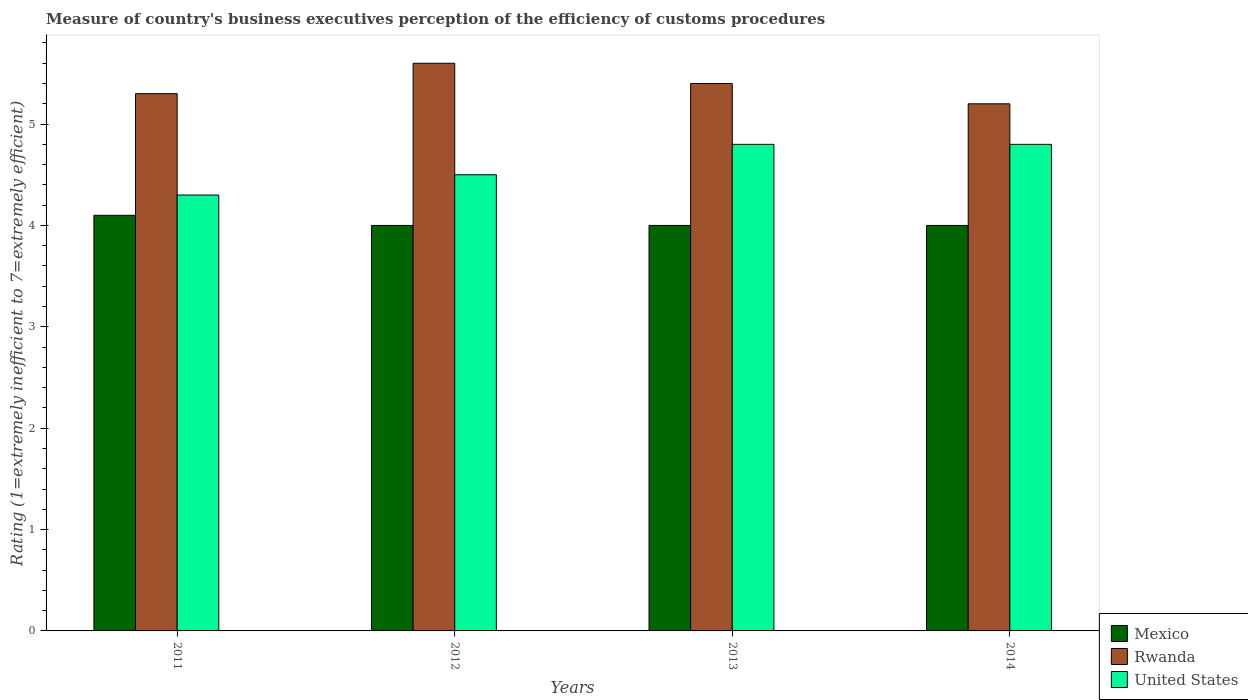Are the number of bars per tick equal to the number of legend labels?
Keep it short and to the point. Yes. How many bars are there on the 2nd tick from the left?
Offer a very short reply. 3. In how many cases, is the number of bars for a given year not equal to the number of legend labels?
Your response must be concise. 0. Across all years, what is the minimum rating of the efficiency of customs procedure in Mexico?
Ensure brevity in your answer.  4. What is the total rating of the efficiency of customs procedure in Rwanda in the graph?
Provide a short and direct response. 21.5. What is the difference between the rating of the efficiency of customs procedure in United States in 2011 and that in 2012?
Ensure brevity in your answer.  -0.2. What is the difference between the rating of the efficiency of customs procedure in Mexico in 2011 and the rating of the efficiency of customs procedure in United States in 2014?
Ensure brevity in your answer.  -0.7. What is the average rating of the efficiency of customs procedure in Mexico per year?
Your answer should be compact. 4.03. What is the ratio of the rating of the efficiency of customs procedure in Rwanda in 2011 to that in 2013?
Give a very brief answer. 0.98. Is the difference between the rating of the efficiency of customs procedure in Rwanda in 2011 and 2012 greater than the difference between the rating of the efficiency of customs procedure in United States in 2011 and 2012?
Offer a very short reply. No. What is the difference between the highest and the second highest rating of the efficiency of customs procedure in Rwanda?
Provide a short and direct response. 0.2. What is the difference between the highest and the lowest rating of the efficiency of customs procedure in Rwanda?
Make the answer very short. 0.4. What does the 2nd bar from the right in 2011 represents?
Your answer should be compact. Rwanda. Is it the case that in every year, the sum of the rating of the efficiency of customs procedure in Mexico and rating of the efficiency of customs procedure in United States is greater than the rating of the efficiency of customs procedure in Rwanda?
Offer a very short reply. Yes. Does the graph contain grids?
Your answer should be compact. No. Where does the legend appear in the graph?
Offer a very short reply. Bottom right. How many legend labels are there?
Your response must be concise. 3. How are the legend labels stacked?
Provide a short and direct response. Vertical. What is the title of the graph?
Your response must be concise. Measure of country's business executives perception of the efficiency of customs procedures. What is the label or title of the Y-axis?
Provide a succinct answer. Rating (1=extremely inefficient to 7=extremely efficient). What is the Rating (1=extremely inefficient to 7=extremely efficient) of Mexico in 2011?
Your response must be concise. 4.1. What is the Rating (1=extremely inefficient to 7=extremely efficient) of Mexico in 2012?
Your answer should be very brief. 4. What is the Rating (1=extremely inefficient to 7=extremely efficient) of Mexico in 2014?
Give a very brief answer. 4. What is the Rating (1=extremely inefficient to 7=extremely efficient) of Rwanda in 2014?
Your response must be concise. 5.2. What is the Rating (1=extremely inefficient to 7=extremely efficient) in United States in 2014?
Offer a terse response. 4.8. Across all years, what is the minimum Rating (1=extremely inefficient to 7=extremely efficient) in Rwanda?
Your response must be concise. 5.2. What is the total Rating (1=extremely inefficient to 7=extremely efficient) of Rwanda in the graph?
Your answer should be compact. 21.5. What is the total Rating (1=extremely inefficient to 7=extremely efficient) in United States in the graph?
Ensure brevity in your answer.  18.4. What is the difference between the Rating (1=extremely inefficient to 7=extremely efficient) of Mexico in 2011 and that in 2012?
Provide a short and direct response. 0.1. What is the difference between the Rating (1=extremely inefficient to 7=extremely efficient) in United States in 2011 and that in 2012?
Your answer should be very brief. -0.2. What is the difference between the Rating (1=extremely inefficient to 7=extremely efficient) of Mexico in 2011 and that in 2013?
Give a very brief answer. 0.1. What is the difference between the Rating (1=extremely inefficient to 7=extremely efficient) of Mexico in 2011 and that in 2014?
Provide a short and direct response. 0.1. What is the difference between the Rating (1=extremely inefficient to 7=extremely efficient) in United States in 2011 and that in 2014?
Your answer should be very brief. -0.5. What is the difference between the Rating (1=extremely inefficient to 7=extremely efficient) in Mexico in 2012 and that in 2013?
Your response must be concise. 0. What is the difference between the Rating (1=extremely inefficient to 7=extremely efficient) in United States in 2012 and that in 2013?
Give a very brief answer. -0.3. What is the difference between the Rating (1=extremely inefficient to 7=extremely efficient) of Mexico in 2012 and that in 2014?
Make the answer very short. 0. What is the difference between the Rating (1=extremely inefficient to 7=extremely efficient) in United States in 2013 and that in 2014?
Your response must be concise. 0. What is the difference between the Rating (1=extremely inefficient to 7=extremely efficient) in Mexico in 2011 and the Rating (1=extremely inefficient to 7=extremely efficient) in Rwanda in 2012?
Ensure brevity in your answer.  -1.5. What is the difference between the Rating (1=extremely inefficient to 7=extremely efficient) in Mexico in 2011 and the Rating (1=extremely inefficient to 7=extremely efficient) in United States in 2012?
Your answer should be very brief. -0.4. What is the difference between the Rating (1=extremely inefficient to 7=extremely efficient) of Mexico in 2011 and the Rating (1=extremely inefficient to 7=extremely efficient) of Rwanda in 2013?
Your answer should be compact. -1.3. What is the difference between the Rating (1=extremely inefficient to 7=extremely efficient) in Rwanda in 2011 and the Rating (1=extremely inefficient to 7=extremely efficient) in United States in 2013?
Your response must be concise. 0.5. What is the difference between the Rating (1=extremely inefficient to 7=extremely efficient) in Mexico in 2011 and the Rating (1=extremely inefficient to 7=extremely efficient) in United States in 2014?
Offer a terse response. -0.7. What is the difference between the Rating (1=extremely inefficient to 7=extremely efficient) of Mexico in 2012 and the Rating (1=extremely inefficient to 7=extremely efficient) of Rwanda in 2013?
Your answer should be very brief. -1.4. What is the difference between the Rating (1=extremely inefficient to 7=extremely efficient) of Mexico in 2013 and the Rating (1=extremely inefficient to 7=extremely efficient) of United States in 2014?
Provide a short and direct response. -0.8. What is the average Rating (1=extremely inefficient to 7=extremely efficient) in Mexico per year?
Keep it short and to the point. 4.03. What is the average Rating (1=extremely inefficient to 7=extremely efficient) of Rwanda per year?
Your answer should be very brief. 5.38. What is the average Rating (1=extremely inefficient to 7=extremely efficient) in United States per year?
Your answer should be compact. 4.6. In the year 2011, what is the difference between the Rating (1=extremely inefficient to 7=extremely efficient) in Mexico and Rating (1=extremely inefficient to 7=extremely efficient) in Rwanda?
Your answer should be compact. -1.2. In the year 2011, what is the difference between the Rating (1=extremely inefficient to 7=extremely efficient) in Mexico and Rating (1=extremely inefficient to 7=extremely efficient) in United States?
Make the answer very short. -0.2. In the year 2011, what is the difference between the Rating (1=extremely inefficient to 7=extremely efficient) in Rwanda and Rating (1=extremely inefficient to 7=extremely efficient) in United States?
Offer a terse response. 1. In the year 2012, what is the difference between the Rating (1=extremely inefficient to 7=extremely efficient) of Mexico and Rating (1=extremely inefficient to 7=extremely efficient) of Rwanda?
Ensure brevity in your answer.  -1.6. In the year 2012, what is the difference between the Rating (1=extremely inefficient to 7=extremely efficient) of Mexico and Rating (1=extremely inefficient to 7=extremely efficient) of United States?
Provide a succinct answer. -0.5. In the year 2014, what is the difference between the Rating (1=extremely inefficient to 7=extremely efficient) of Mexico and Rating (1=extremely inefficient to 7=extremely efficient) of Rwanda?
Your answer should be very brief. -1.2. In the year 2014, what is the difference between the Rating (1=extremely inefficient to 7=extremely efficient) in Mexico and Rating (1=extremely inefficient to 7=extremely efficient) in United States?
Ensure brevity in your answer.  -0.8. What is the ratio of the Rating (1=extremely inefficient to 7=extremely efficient) of Mexico in 2011 to that in 2012?
Your answer should be compact. 1.02. What is the ratio of the Rating (1=extremely inefficient to 7=extremely efficient) of Rwanda in 2011 to that in 2012?
Give a very brief answer. 0.95. What is the ratio of the Rating (1=extremely inefficient to 7=extremely efficient) in United States in 2011 to that in 2012?
Keep it short and to the point. 0.96. What is the ratio of the Rating (1=extremely inefficient to 7=extremely efficient) of Rwanda in 2011 to that in 2013?
Your answer should be compact. 0.98. What is the ratio of the Rating (1=extremely inefficient to 7=extremely efficient) in United States in 2011 to that in 2013?
Offer a very short reply. 0.9. What is the ratio of the Rating (1=extremely inefficient to 7=extremely efficient) in Rwanda in 2011 to that in 2014?
Provide a short and direct response. 1.02. What is the ratio of the Rating (1=extremely inefficient to 7=extremely efficient) in United States in 2011 to that in 2014?
Ensure brevity in your answer.  0.9. What is the ratio of the Rating (1=extremely inefficient to 7=extremely efficient) in United States in 2012 to that in 2013?
Your response must be concise. 0.94. What is the ratio of the Rating (1=extremely inefficient to 7=extremely efficient) in Mexico in 2012 to that in 2014?
Make the answer very short. 1. What is the ratio of the Rating (1=extremely inefficient to 7=extremely efficient) in Rwanda in 2012 to that in 2014?
Make the answer very short. 1.08. What is the ratio of the Rating (1=extremely inefficient to 7=extremely efficient) of United States in 2012 to that in 2014?
Provide a succinct answer. 0.94. What is the ratio of the Rating (1=extremely inefficient to 7=extremely efficient) of Rwanda in 2013 to that in 2014?
Offer a very short reply. 1.04. What is the ratio of the Rating (1=extremely inefficient to 7=extremely efficient) in United States in 2013 to that in 2014?
Offer a very short reply. 1. What is the difference between the highest and the second highest Rating (1=extremely inefficient to 7=extremely efficient) in Mexico?
Ensure brevity in your answer.  0.1. What is the difference between the highest and the second highest Rating (1=extremely inefficient to 7=extremely efficient) in United States?
Your answer should be very brief. 0. What is the difference between the highest and the lowest Rating (1=extremely inefficient to 7=extremely efficient) in Mexico?
Your answer should be compact. 0.1. 